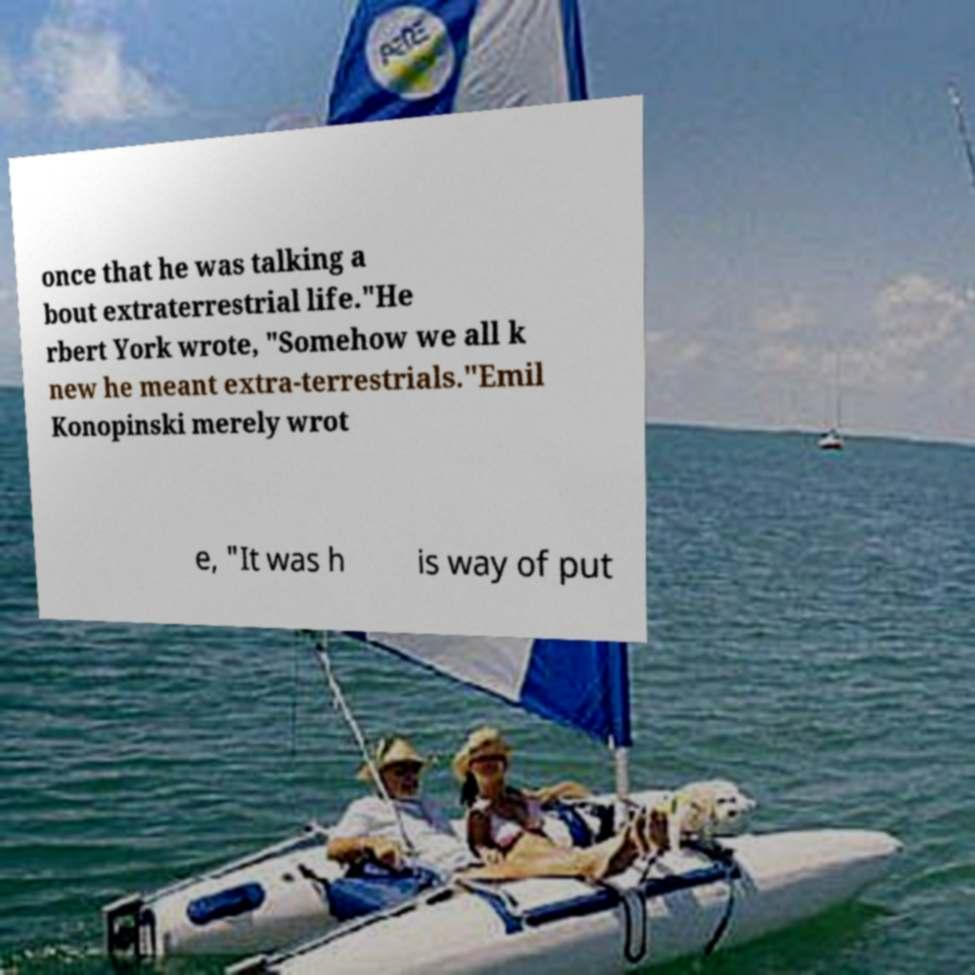For documentation purposes, I need the text within this image transcribed. Could you provide that? once that he was talking a bout extraterrestrial life."He rbert York wrote, "Somehow we all k new he meant extra-terrestrials."Emil Konopinski merely wrot e, "It was h is way of put 